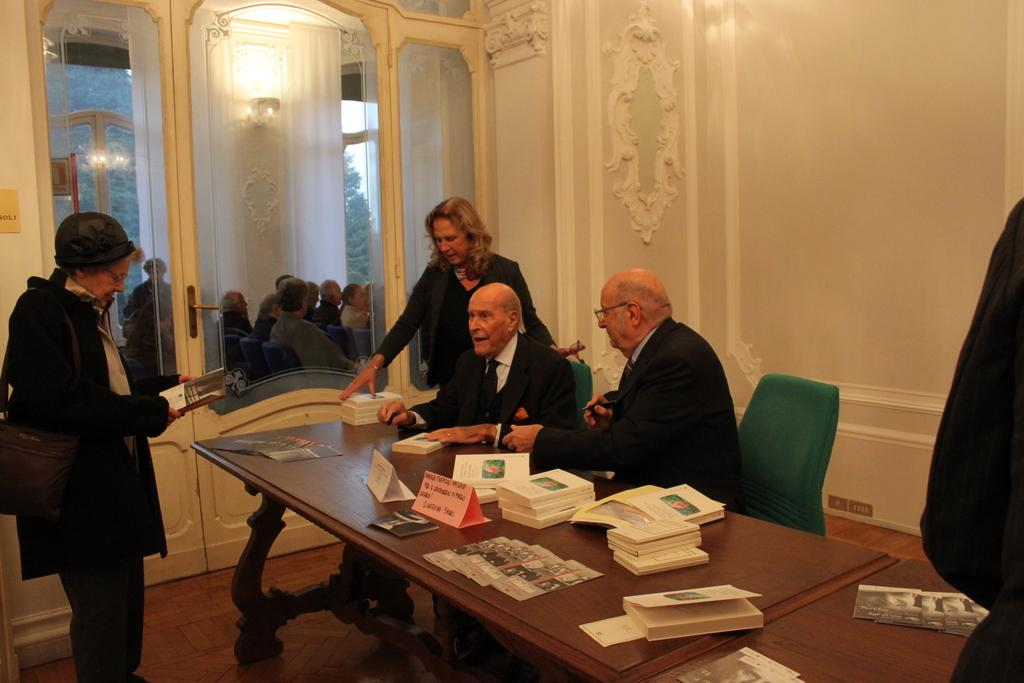What type of structure can be seen in the image? There is a wall in the image. Is there any entrance visible in the image? Yes, there is a door in the image. What are the people in the image doing? There are two people sitting on chairs in the image. What is on the table in the image? There are books and a poster on the table. How does the door help the people in the image? The door does not actively help the people in the image; it is simply an entrance or exit to the room. 